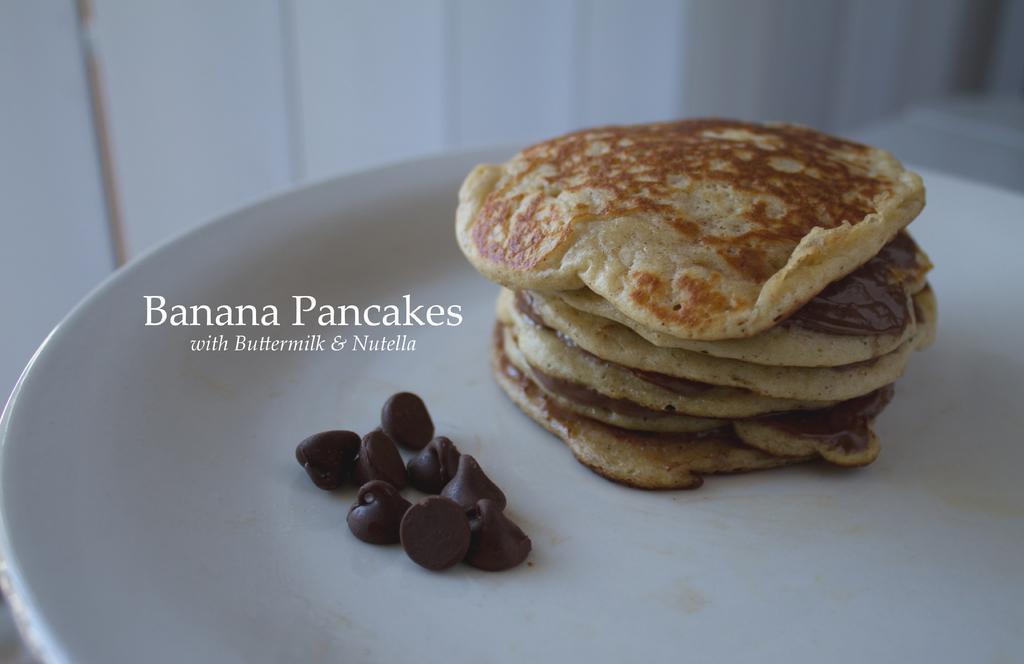Please provide a concise description of this image. In this picture we can see food items placed on a white plate, some text and in the background we can see the wall. 